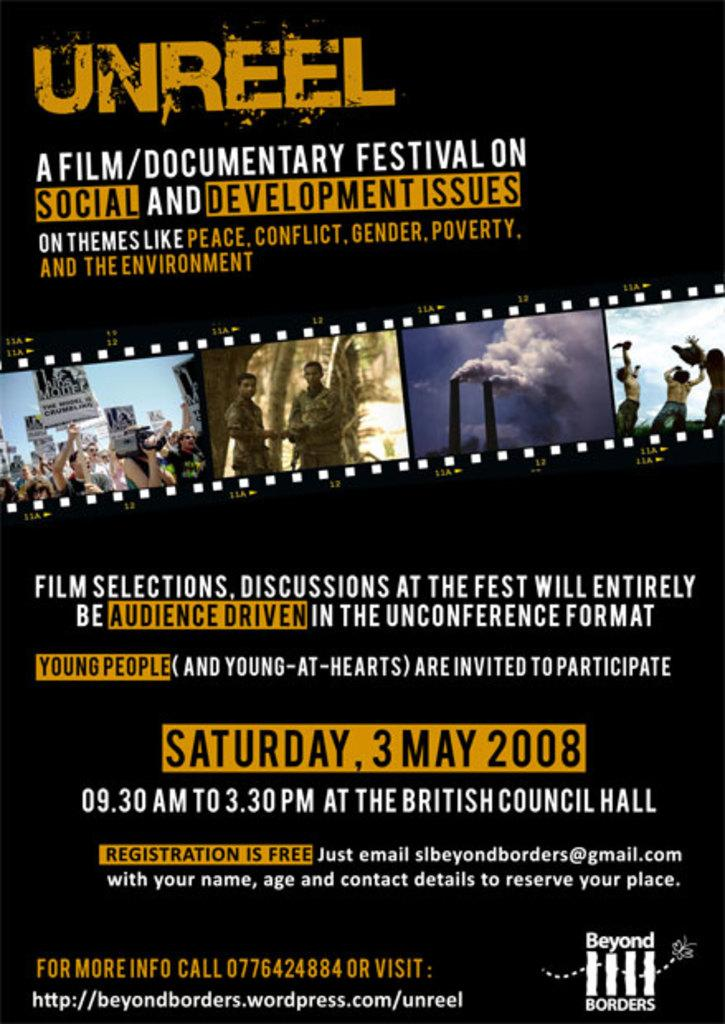<image>
Create a compact narrative representing the image presented. Poster for a festival that takes place on May the 3rd. 